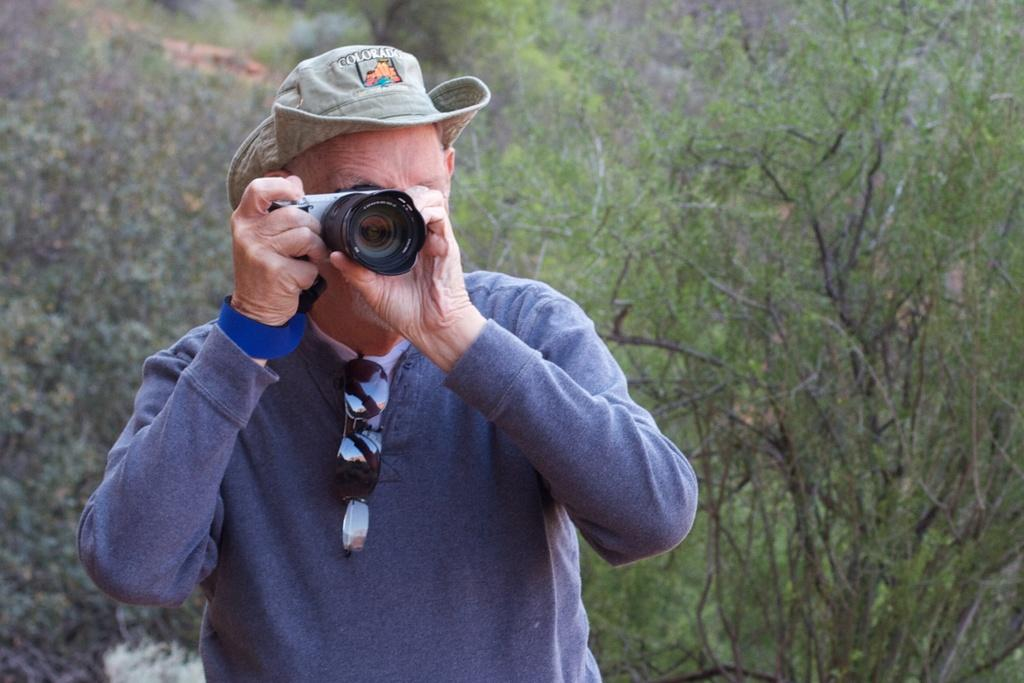What color is the jacket that the person is wearing in the image? The person is wearing a blue jacket in the image. What type of headwear is the person wearing? The person is wearing a hat in the image. What is the person holding in the image? The person is holding a camera in the image. What is the person doing with the camera? The person is capturing an image with the camera. Where are the glasses and goggles located in the image? The glasses and goggles are hanging on the person's jacket in the image. What can be seen in the background of the image? There are trees in the background of the image. What type of park is visible in the image? There is no park visible in the image; it features a person wearing a blue jacket, a hat, and holding a camera while capturing an image. 